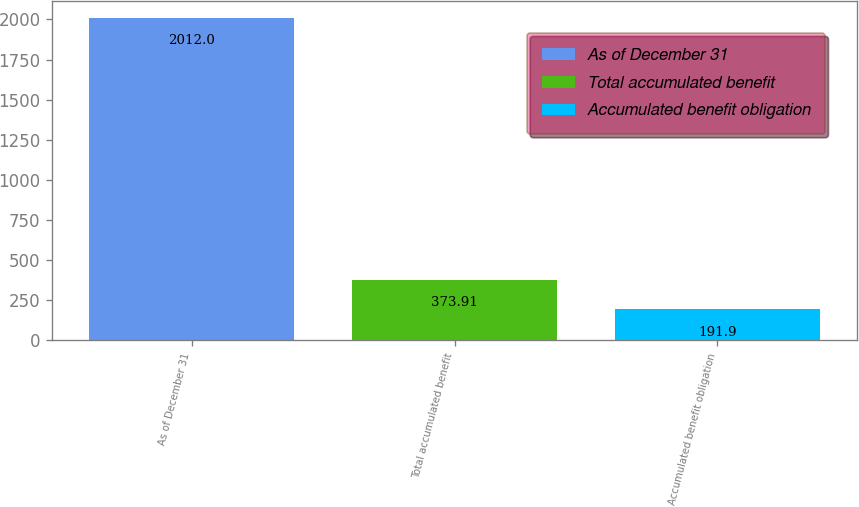<chart> <loc_0><loc_0><loc_500><loc_500><bar_chart><fcel>As of December 31<fcel>Total accumulated benefit<fcel>Accumulated benefit obligation<nl><fcel>2012<fcel>373.91<fcel>191.9<nl></chart> 